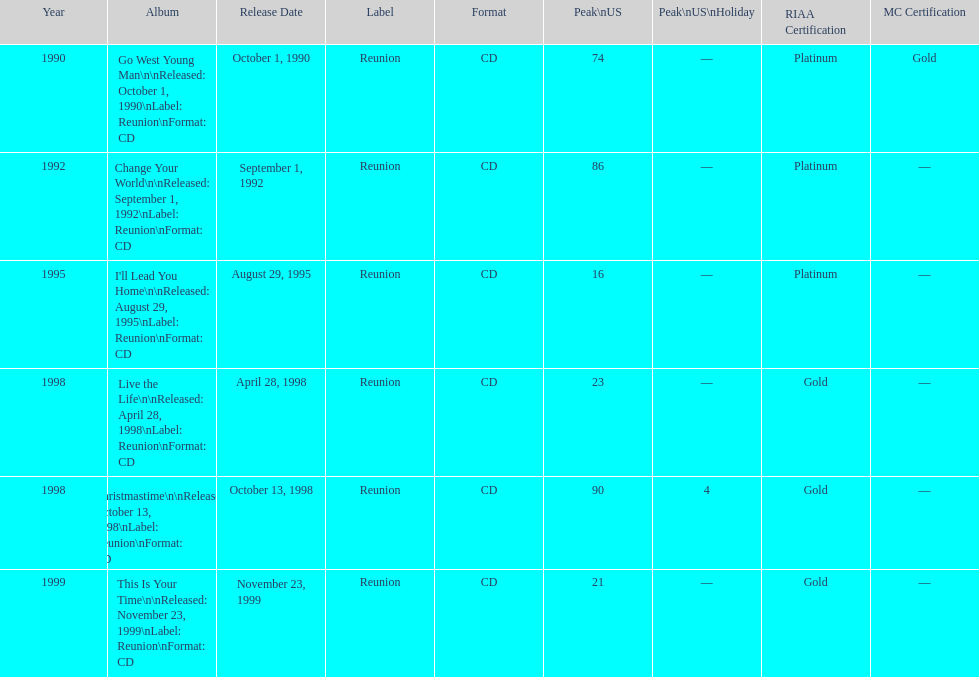Which michael w smith album had the highest ranking on the us chart? I'll Lead You Home. 